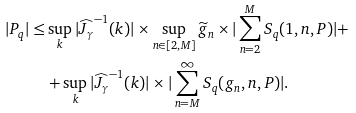<formula> <loc_0><loc_0><loc_500><loc_500>| P _ { q } | \leq & \sup _ { k } | \widehat { J _ { \gamma } } ^ { - 1 } ( k ) | \times \sup _ { n \in [ 2 , M ] } \widetilde { g } _ { n } \times | \sum _ { n = 2 } ^ { M } S _ { q } ( 1 , n , P ) | + \\ & + \sup _ { k } | \widehat { J _ { \gamma } } ^ { - 1 } ( k ) | \times | \sum _ { n = M } ^ { \infty } S _ { q } ( g _ { n } , n , P ) | .</formula> 